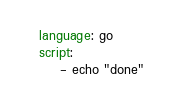Convert code to text. <code><loc_0><loc_0><loc_500><loc_500><_YAML_>language: go
script: 
    - echo "done"
</code> 